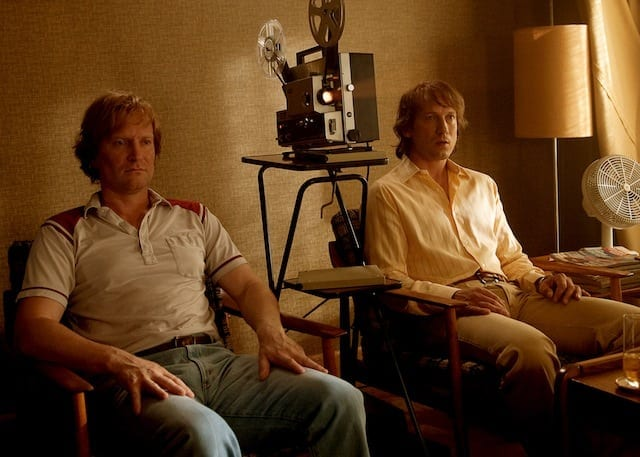What creative title would you give to this image? Dust and Dreams: A Cinematic Memory Unfolds 